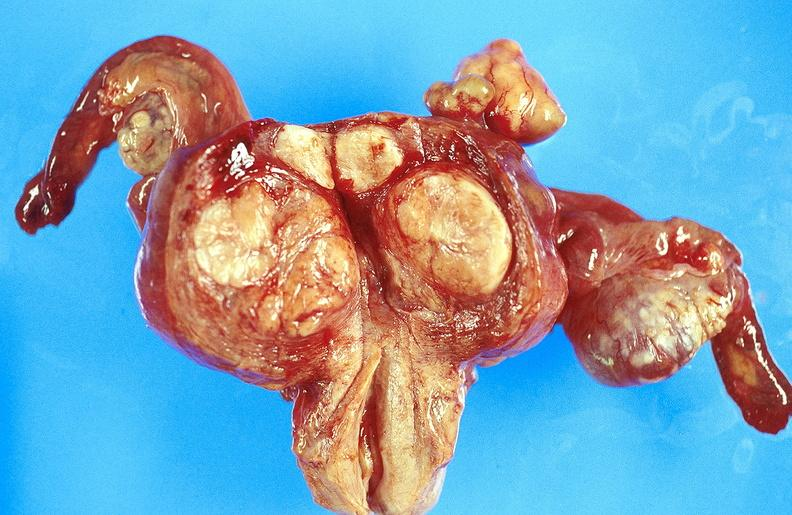does cardiovascular show uterus, leiomyoma?
Answer the question using a single word or phrase. No 